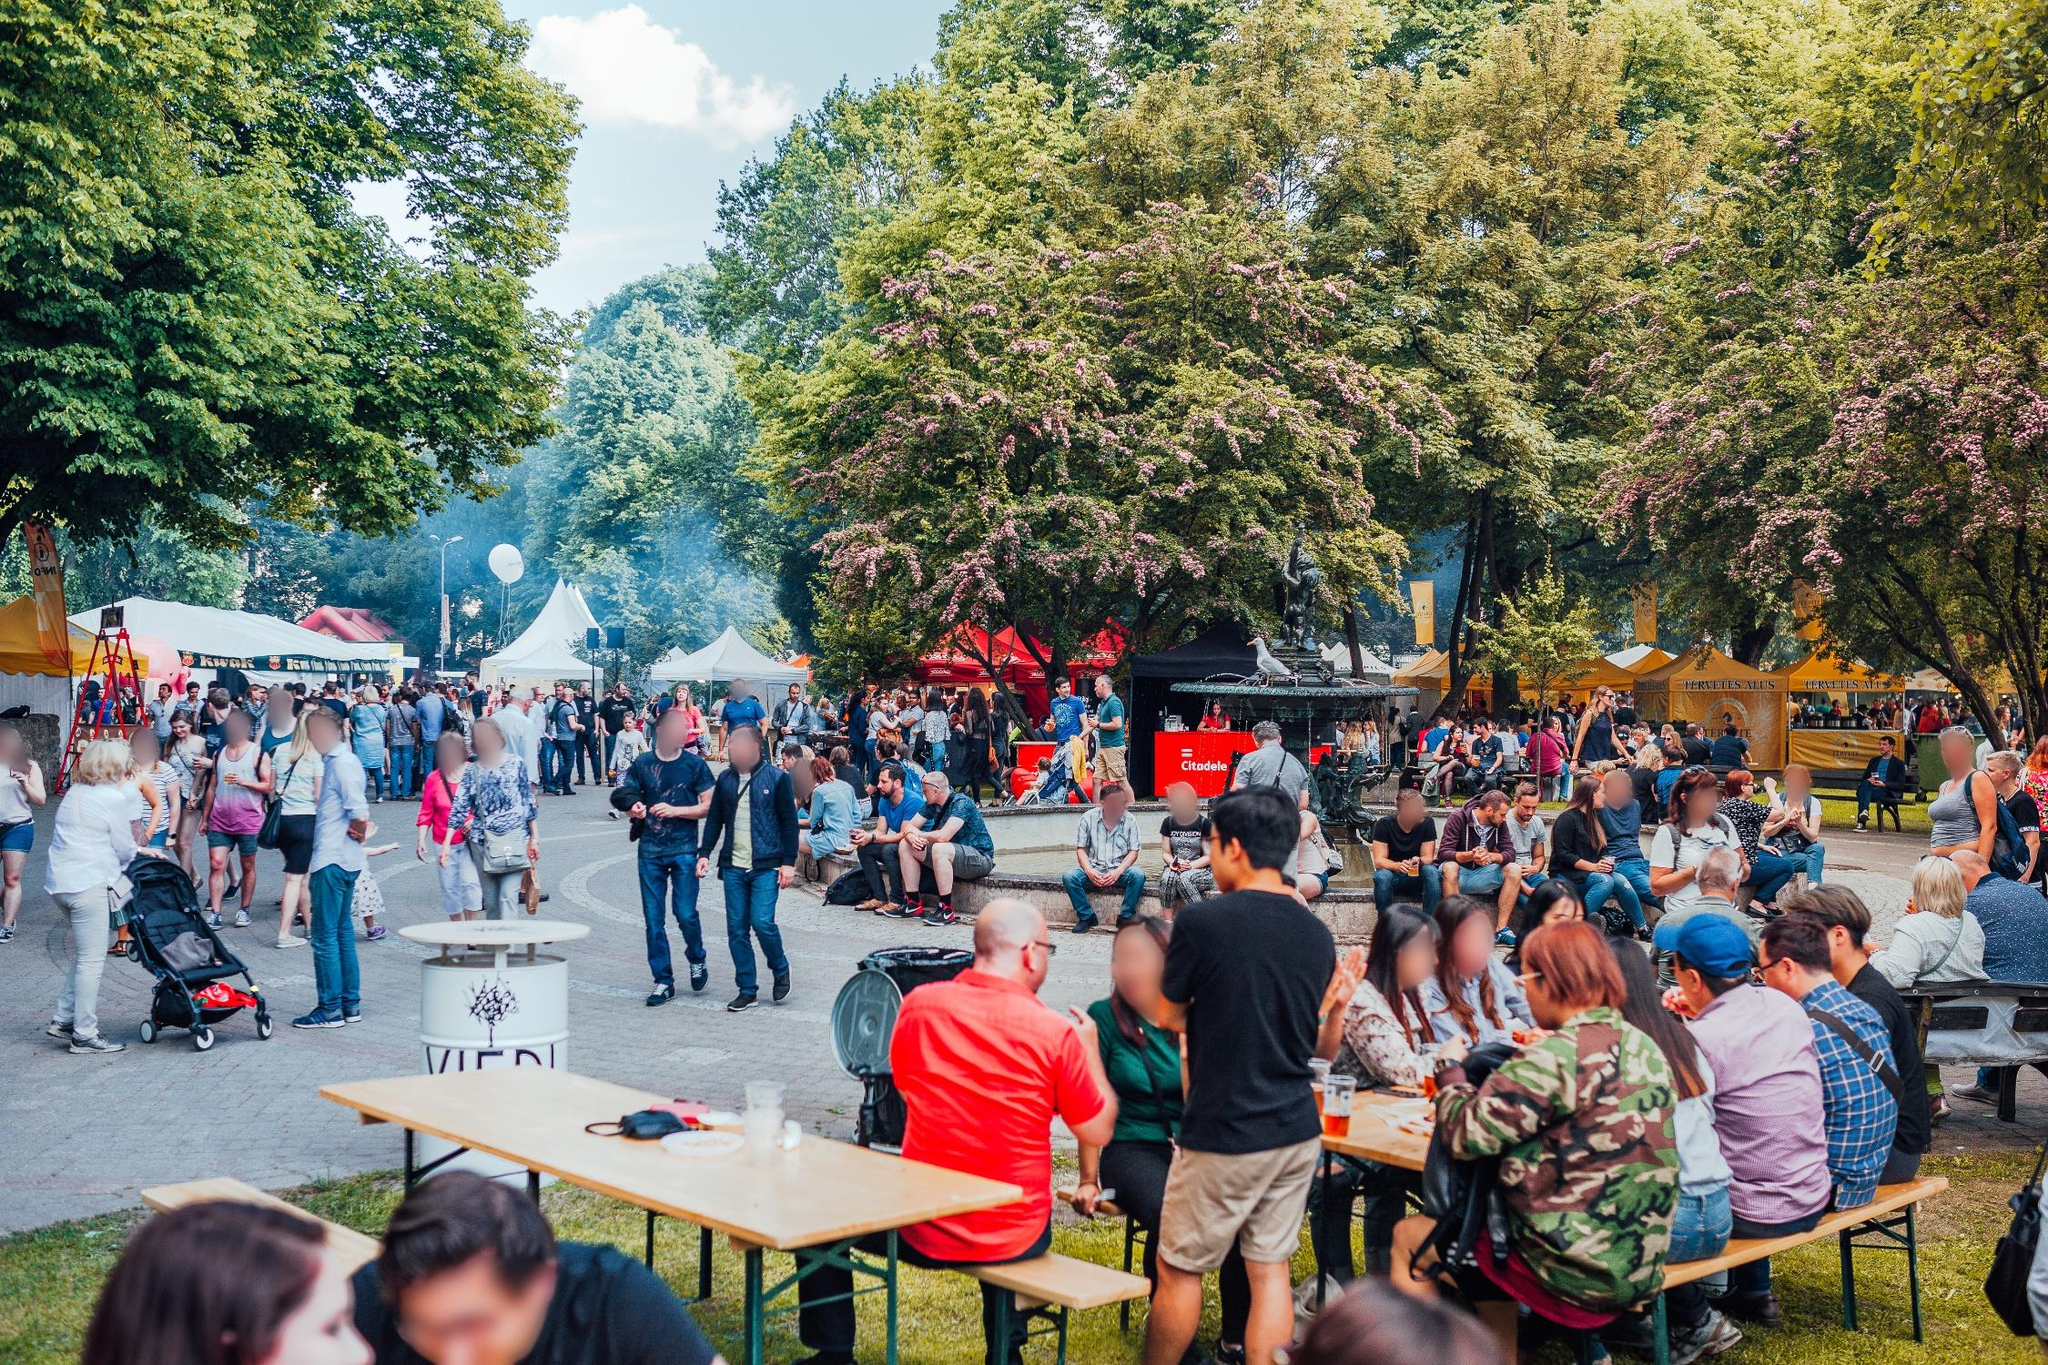Can you spot any entertainment or activities for children in this festival scene? While the image primarily shows adults, the environment suggests family-friendly activities might be present. There might be a play area or child-centric entertainment such as face-painting, balloon animals, or small carnival games, although they're not distinctly visible in this specific shot. 